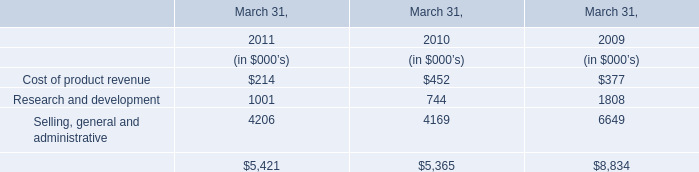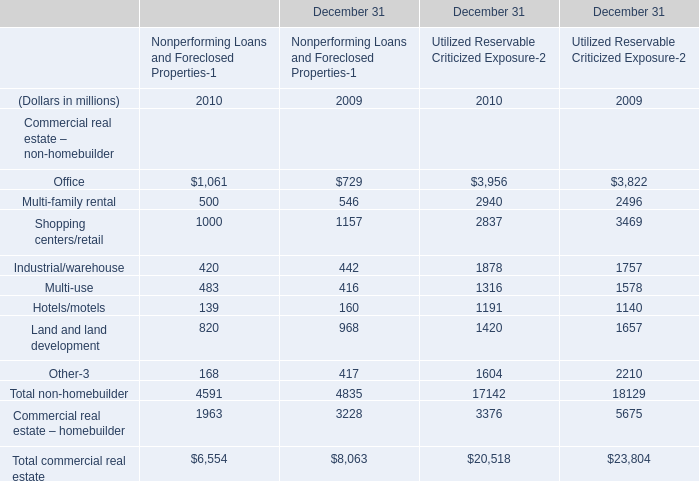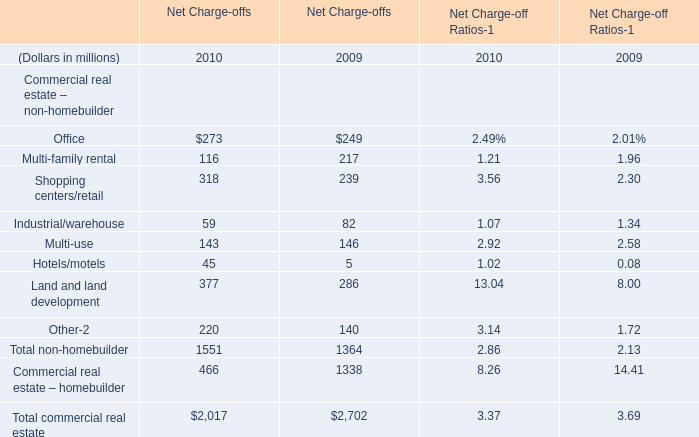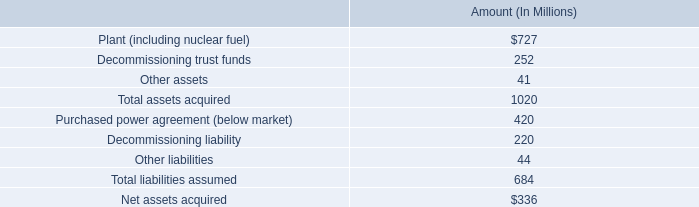What's the total amount of the Office in the years where Office is greater than 1? (in million) 
Computations: (273 + 249)
Answer: 522.0. 